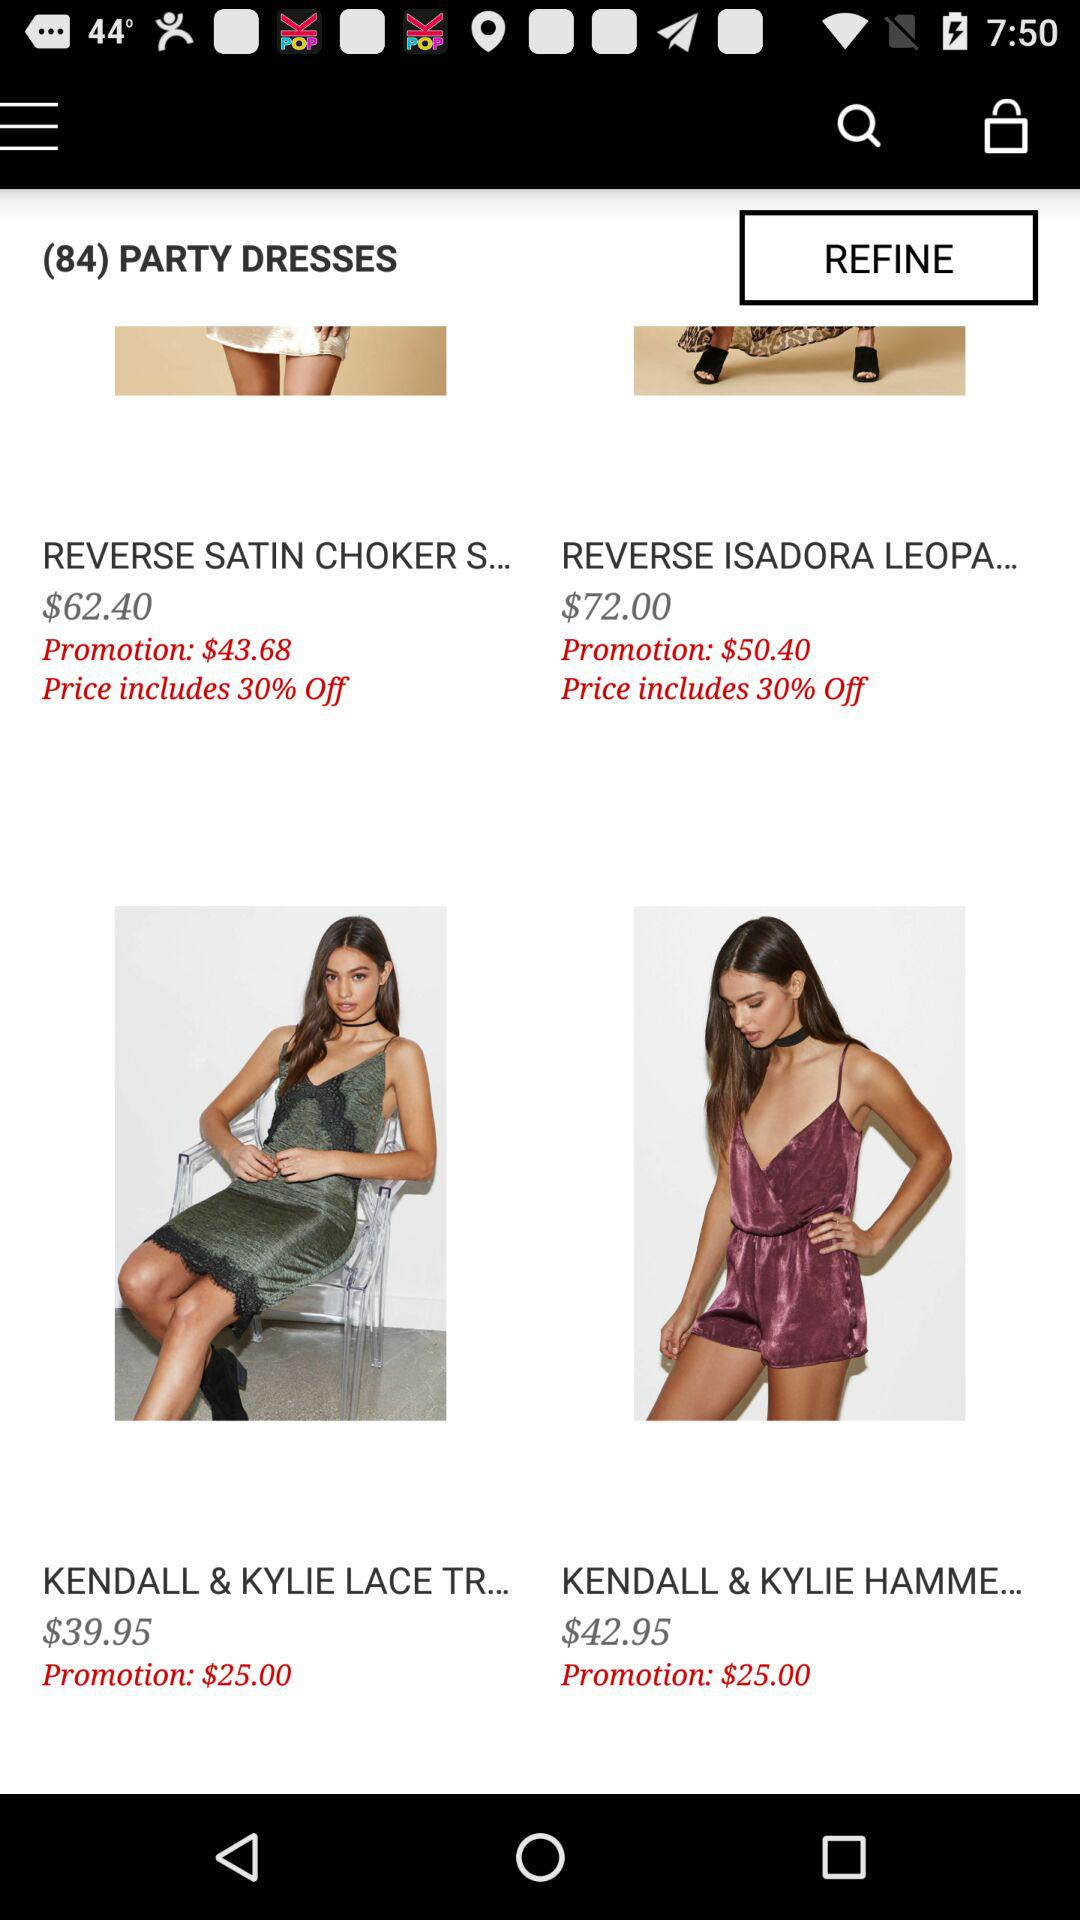How many party dresses are there? There are 84 party dresses. 